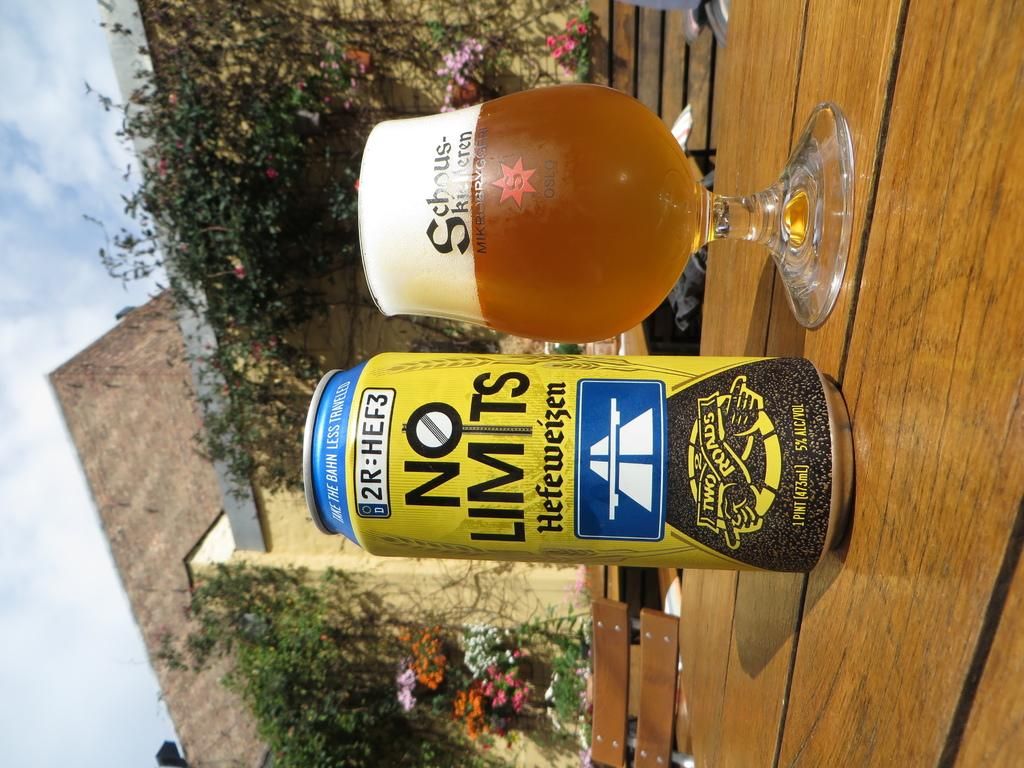Provide a one-sentence caption for the provided image. A can of NO LIMITS sits on a table next to a full glass. 